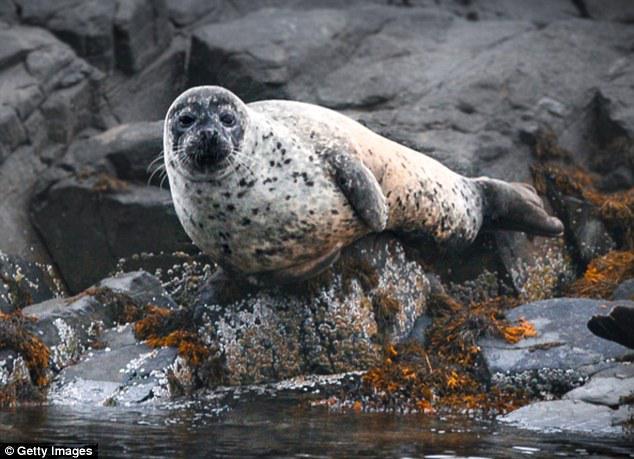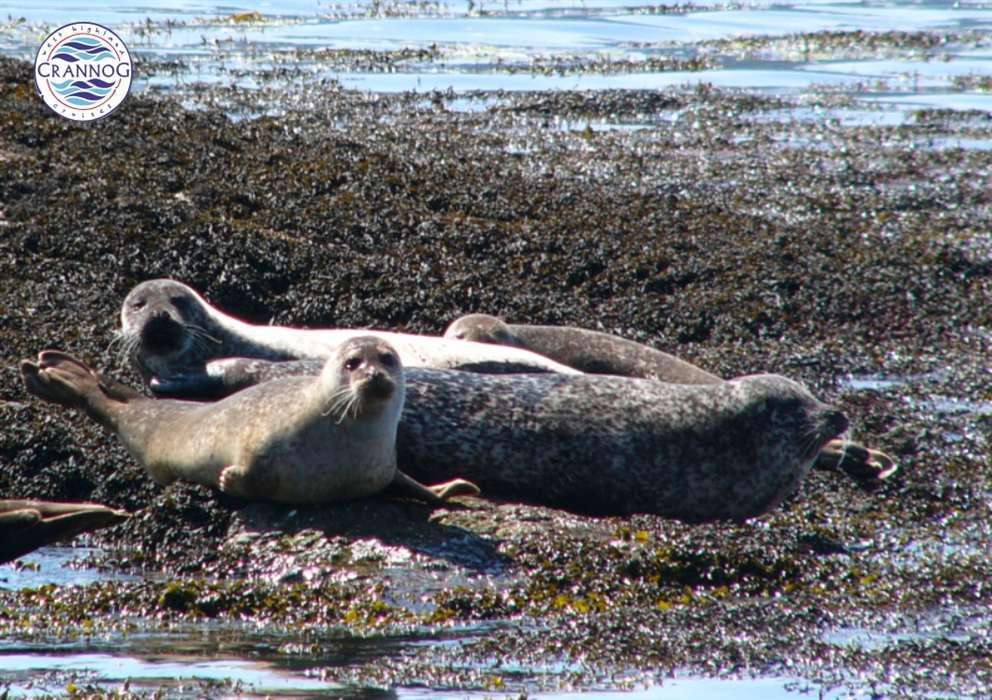The first image is the image on the left, the second image is the image on the right. Considering the images on both sides, is "In one image, a seal is in the water." valid? Answer yes or no. No. The first image is the image on the left, the second image is the image on the right. For the images shown, is this caption "a single animal is on a rock in the right pic" true? Answer yes or no. No. 